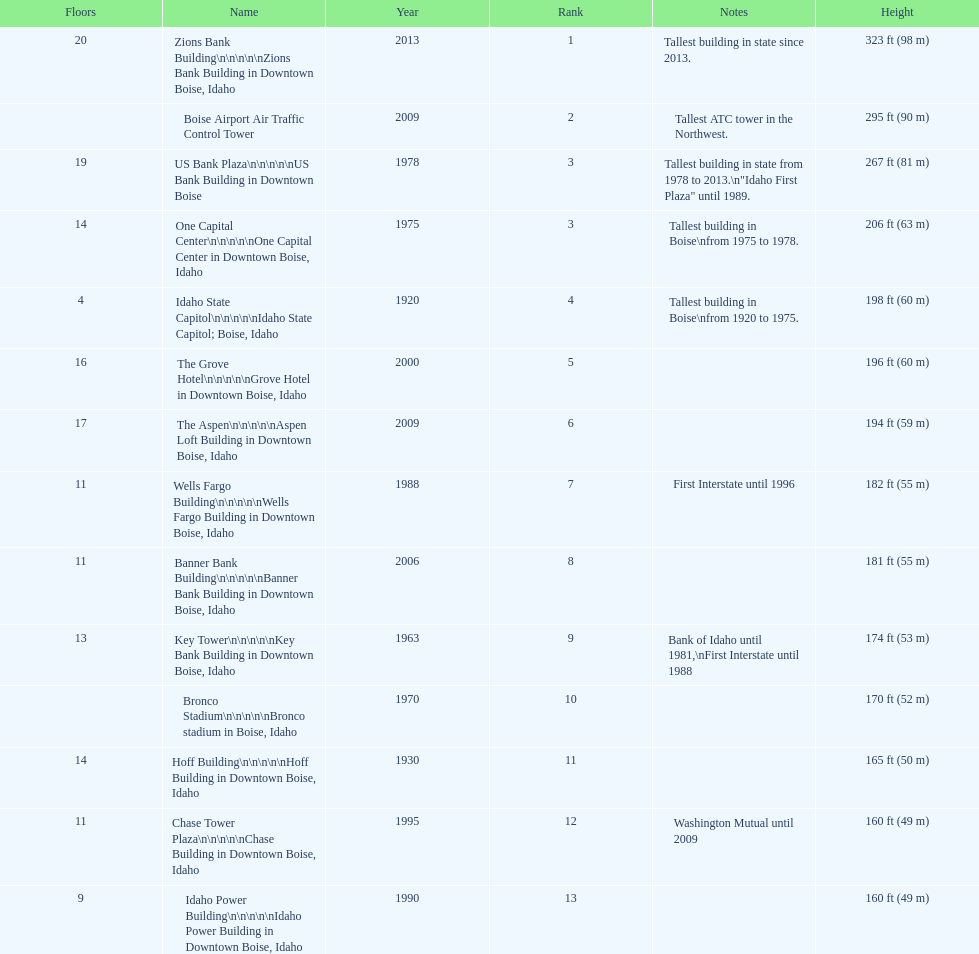What is the number of floors of the oldest building? 4. 